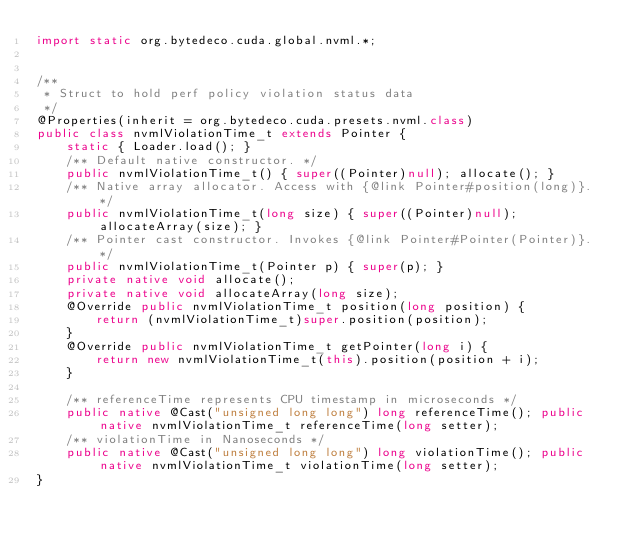Convert code to text. <code><loc_0><loc_0><loc_500><loc_500><_Java_>import static org.bytedeco.cuda.global.nvml.*;


/**
 * Struct to hold perf policy violation status data
 */
@Properties(inherit = org.bytedeco.cuda.presets.nvml.class)
public class nvmlViolationTime_t extends Pointer {
    static { Loader.load(); }
    /** Default native constructor. */
    public nvmlViolationTime_t() { super((Pointer)null); allocate(); }
    /** Native array allocator. Access with {@link Pointer#position(long)}. */
    public nvmlViolationTime_t(long size) { super((Pointer)null); allocateArray(size); }
    /** Pointer cast constructor. Invokes {@link Pointer#Pointer(Pointer)}. */
    public nvmlViolationTime_t(Pointer p) { super(p); }
    private native void allocate();
    private native void allocateArray(long size);
    @Override public nvmlViolationTime_t position(long position) {
        return (nvmlViolationTime_t)super.position(position);
    }
    @Override public nvmlViolationTime_t getPointer(long i) {
        return new nvmlViolationTime_t(this).position(position + i);
    }

    /** referenceTime represents CPU timestamp in microseconds */
    public native @Cast("unsigned long long") long referenceTime(); public native nvmlViolationTime_t referenceTime(long setter);
    /** violationTime in Nanoseconds */
    public native @Cast("unsigned long long") long violationTime(); public native nvmlViolationTime_t violationTime(long setter);
}
</code> 